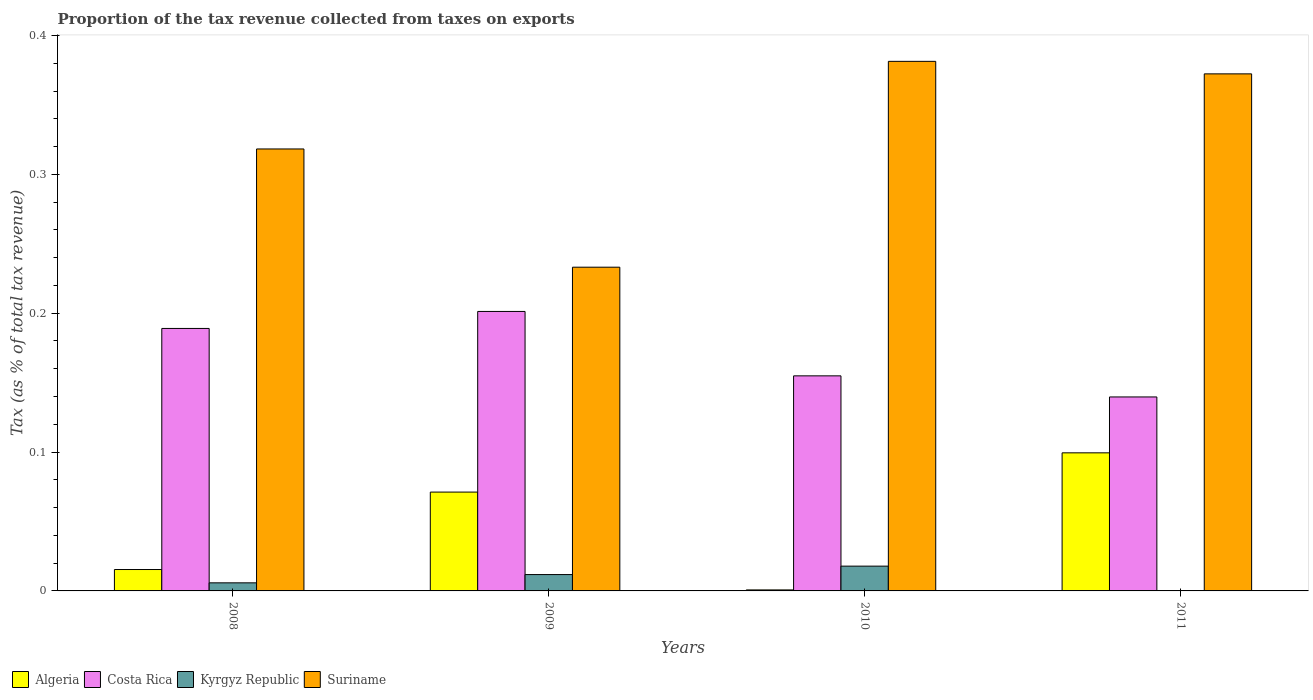How many groups of bars are there?
Your response must be concise. 4. How many bars are there on the 1st tick from the left?
Give a very brief answer. 4. How many bars are there on the 3rd tick from the right?
Provide a succinct answer. 4. What is the label of the 3rd group of bars from the left?
Ensure brevity in your answer.  2010. What is the proportion of the tax revenue collected in Algeria in 2009?
Your response must be concise. 0.07. Across all years, what is the maximum proportion of the tax revenue collected in Costa Rica?
Offer a terse response. 0.2. Across all years, what is the minimum proportion of the tax revenue collected in Suriname?
Your response must be concise. 0.23. What is the total proportion of the tax revenue collected in Algeria in the graph?
Provide a succinct answer. 0.19. What is the difference between the proportion of the tax revenue collected in Suriname in 2009 and that in 2010?
Offer a very short reply. -0.15. What is the difference between the proportion of the tax revenue collected in Algeria in 2011 and the proportion of the tax revenue collected in Costa Rica in 2010?
Make the answer very short. -0.06. What is the average proportion of the tax revenue collected in Costa Rica per year?
Offer a very short reply. 0.17. In the year 2010, what is the difference between the proportion of the tax revenue collected in Suriname and proportion of the tax revenue collected in Costa Rica?
Give a very brief answer. 0.23. What is the ratio of the proportion of the tax revenue collected in Suriname in 2009 to that in 2010?
Keep it short and to the point. 0.61. What is the difference between the highest and the second highest proportion of the tax revenue collected in Suriname?
Offer a very short reply. 0.01. What is the difference between the highest and the lowest proportion of the tax revenue collected in Algeria?
Your answer should be compact. 0.1. Is the sum of the proportion of the tax revenue collected in Costa Rica in 2010 and 2011 greater than the maximum proportion of the tax revenue collected in Algeria across all years?
Offer a very short reply. Yes. Is it the case that in every year, the sum of the proportion of the tax revenue collected in Suriname and proportion of the tax revenue collected in Costa Rica is greater than the sum of proportion of the tax revenue collected in Algeria and proportion of the tax revenue collected in Kyrgyz Republic?
Your answer should be very brief. Yes. How many bars are there?
Offer a terse response. 15. What is the difference between two consecutive major ticks on the Y-axis?
Make the answer very short. 0.1. Does the graph contain grids?
Make the answer very short. No. Where does the legend appear in the graph?
Make the answer very short. Bottom left. What is the title of the graph?
Make the answer very short. Proportion of the tax revenue collected from taxes on exports. Does "Europe(all income levels)" appear as one of the legend labels in the graph?
Make the answer very short. No. What is the label or title of the X-axis?
Your answer should be very brief. Years. What is the label or title of the Y-axis?
Your answer should be compact. Tax (as % of total tax revenue). What is the Tax (as % of total tax revenue) in Algeria in 2008?
Make the answer very short. 0.02. What is the Tax (as % of total tax revenue) in Costa Rica in 2008?
Offer a terse response. 0.19. What is the Tax (as % of total tax revenue) of Kyrgyz Republic in 2008?
Your answer should be very brief. 0.01. What is the Tax (as % of total tax revenue) of Suriname in 2008?
Provide a short and direct response. 0.32. What is the Tax (as % of total tax revenue) of Algeria in 2009?
Your response must be concise. 0.07. What is the Tax (as % of total tax revenue) in Costa Rica in 2009?
Your answer should be compact. 0.2. What is the Tax (as % of total tax revenue) of Kyrgyz Republic in 2009?
Offer a very short reply. 0.01. What is the Tax (as % of total tax revenue) in Suriname in 2009?
Keep it short and to the point. 0.23. What is the Tax (as % of total tax revenue) of Algeria in 2010?
Provide a succinct answer. 0. What is the Tax (as % of total tax revenue) in Costa Rica in 2010?
Provide a succinct answer. 0.15. What is the Tax (as % of total tax revenue) of Kyrgyz Republic in 2010?
Your answer should be very brief. 0.02. What is the Tax (as % of total tax revenue) of Suriname in 2010?
Your answer should be very brief. 0.38. What is the Tax (as % of total tax revenue) in Algeria in 2011?
Keep it short and to the point. 0.1. What is the Tax (as % of total tax revenue) in Costa Rica in 2011?
Provide a succinct answer. 0.14. What is the Tax (as % of total tax revenue) in Kyrgyz Republic in 2011?
Offer a very short reply. 0. What is the Tax (as % of total tax revenue) of Suriname in 2011?
Provide a succinct answer. 0.37. Across all years, what is the maximum Tax (as % of total tax revenue) of Algeria?
Provide a short and direct response. 0.1. Across all years, what is the maximum Tax (as % of total tax revenue) in Costa Rica?
Give a very brief answer. 0.2. Across all years, what is the maximum Tax (as % of total tax revenue) in Kyrgyz Republic?
Give a very brief answer. 0.02. Across all years, what is the maximum Tax (as % of total tax revenue) of Suriname?
Your answer should be compact. 0.38. Across all years, what is the minimum Tax (as % of total tax revenue) in Algeria?
Ensure brevity in your answer.  0. Across all years, what is the minimum Tax (as % of total tax revenue) of Costa Rica?
Provide a short and direct response. 0.14. Across all years, what is the minimum Tax (as % of total tax revenue) in Suriname?
Offer a terse response. 0.23. What is the total Tax (as % of total tax revenue) of Algeria in the graph?
Make the answer very short. 0.19. What is the total Tax (as % of total tax revenue) of Costa Rica in the graph?
Ensure brevity in your answer.  0.68. What is the total Tax (as % of total tax revenue) of Kyrgyz Republic in the graph?
Keep it short and to the point. 0.04. What is the total Tax (as % of total tax revenue) of Suriname in the graph?
Ensure brevity in your answer.  1.31. What is the difference between the Tax (as % of total tax revenue) of Algeria in 2008 and that in 2009?
Your answer should be very brief. -0.06. What is the difference between the Tax (as % of total tax revenue) of Costa Rica in 2008 and that in 2009?
Offer a terse response. -0.01. What is the difference between the Tax (as % of total tax revenue) of Kyrgyz Republic in 2008 and that in 2009?
Your response must be concise. -0.01. What is the difference between the Tax (as % of total tax revenue) in Suriname in 2008 and that in 2009?
Your answer should be compact. 0.09. What is the difference between the Tax (as % of total tax revenue) of Algeria in 2008 and that in 2010?
Your answer should be compact. 0.01. What is the difference between the Tax (as % of total tax revenue) in Costa Rica in 2008 and that in 2010?
Ensure brevity in your answer.  0.03. What is the difference between the Tax (as % of total tax revenue) in Kyrgyz Republic in 2008 and that in 2010?
Your response must be concise. -0.01. What is the difference between the Tax (as % of total tax revenue) of Suriname in 2008 and that in 2010?
Make the answer very short. -0.06. What is the difference between the Tax (as % of total tax revenue) of Algeria in 2008 and that in 2011?
Give a very brief answer. -0.08. What is the difference between the Tax (as % of total tax revenue) of Costa Rica in 2008 and that in 2011?
Your answer should be very brief. 0.05. What is the difference between the Tax (as % of total tax revenue) in Suriname in 2008 and that in 2011?
Keep it short and to the point. -0.05. What is the difference between the Tax (as % of total tax revenue) of Algeria in 2009 and that in 2010?
Offer a very short reply. 0.07. What is the difference between the Tax (as % of total tax revenue) in Costa Rica in 2009 and that in 2010?
Your answer should be very brief. 0.05. What is the difference between the Tax (as % of total tax revenue) of Kyrgyz Republic in 2009 and that in 2010?
Ensure brevity in your answer.  -0.01. What is the difference between the Tax (as % of total tax revenue) in Suriname in 2009 and that in 2010?
Offer a very short reply. -0.15. What is the difference between the Tax (as % of total tax revenue) of Algeria in 2009 and that in 2011?
Provide a succinct answer. -0.03. What is the difference between the Tax (as % of total tax revenue) in Costa Rica in 2009 and that in 2011?
Ensure brevity in your answer.  0.06. What is the difference between the Tax (as % of total tax revenue) of Suriname in 2009 and that in 2011?
Offer a terse response. -0.14. What is the difference between the Tax (as % of total tax revenue) of Algeria in 2010 and that in 2011?
Offer a terse response. -0.1. What is the difference between the Tax (as % of total tax revenue) of Costa Rica in 2010 and that in 2011?
Offer a terse response. 0.02. What is the difference between the Tax (as % of total tax revenue) in Suriname in 2010 and that in 2011?
Make the answer very short. 0.01. What is the difference between the Tax (as % of total tax revenue) in Algeria in 2008 and the Tax (as % of total tax revenue) in Costa Rica in 2009?
Your answer should be compact. -0.19. What is the difference between the Tax (as % of total tax revenue) of Algeria in 2008 and the Tax (as % of total tax revenue) of Kyrgyz Republic in 2009?
Keep it short and to the point. 0. What is the difference between the Tax (as % of total tax revenue) in Algeria in 2008 and the Tax (as % of total tax revenue) in Suriname in 2009?
Ensure brevity in your answer.  -0.22. What is the difference between the Tax (as % of total tax revenue) of Costa Rica in 2008 and the Tax (as % of total tax revenue) of Kyrgyz Republic in 2009?
Your answer should be compact. 0.18. What is the difference between the Tax (as % of total tax revenue) of Costa Rica in 2008 and the Tax (as % of total tax revenue) of Suriname in 2009?
Your answer should be compact. -0.04. What is the difference between the Tax (as % of total tax revenue) of Kyrgyz Republic in 2008 and the Tax (as % of total tax revenue) of Suriname in 2009?
Your response must be concise. -0.23. What is the difference between the Tax (as % of total tax revenue) in Algeria in 2008 and the Tax (as % of total tax revenue) in Costa Rica in 2010?
Provide a short and direct response. -0.14. What is the difference between the Tax (as % of total tax revenue) of Algeria in 2008 and the Tax (as % of total tax revenue) of Kyrgyz Republic in 2010?
Make the answer very short. -0. What is the difference between the Tax (as % of total tax revenue) in Algeria in 2008 and the Tax (as % of total tax revenue) in Suriname in 2010?
Ensure brevity in your answer.  -0.37. What is the difference between the Tax (as % of total tax revenue) in Costa Rica in 2008 and the Tax (as % of total tax revenue) in Kyrgyz Republic in 2010?
Your answer should be compact. 0.17. What is the difference between the Tax (as % of total tax revenue) in Costa Rica in 2008 and the Tax (as % of total tax revenue) in Suriname in 2010?
Provide a short and direct response. -0.19. What is the difference between the Tax (as % of total tax revenue) in Kyrgyz Republic in 2008 and the Tax (as % of total tax revenue) in Suriname in 2010?
Give a very brief answer. -0.38. What is the difference between the Tax (as % of total tax revenue) in Algeria in 2008 and the Tax (as % of total tax revenue) in Costa Rica in 2011?
Offer a very short reply. -0.12. What is the difference between the Tax (as % of total tax revenue) in Algeria in 2008 and the Tax (as % of total tax revenue) in Suriname in 2011?
Ensure brevity in your answer.  -0.36. What is the difference between the Tax (as % of total tax revenue) in Costa Rica in 2008 and the Tax (as % of total tax revenue) in Suriname in 2011?
Make the answer very short. -0.18. What is the difference between the Tax (as % of total tax revenue) of Kyrgyz Republic in 2008 and the Tax (as % of total tax revenue) of Suriname in 2011?
Keep it short and to the point. -0.37. What is the difference between the Tax (as % of total tax revenue) of Algeria in 2009 and the Tax (as % of total tax revenue) of Costa Rica in 2010?
Make the answer very short. -0.08. What is the difference between the Tax (as % of total tax revenue) in Algeria in 2009 and the Tax (as % of total tax revenue) in Kyrgyz Republic in 2010?
Make the answer very short. 0.05. What is the difference between the Tax (as % of total tax revenue) in Algeria in 2009 and the Tax (as % of total tax revenue) in Suriname in 2010?
Make the answer very short. -0.31. What is the difference between the Tax (as % of total tax revenue) of Costa Rica in 2009 and the Tax (as % of total tax revenue) of Kyrgyz Republic in 2010?
Make the answer very short. 0.18. What is the difference between the Tax (as % of total tax revenue) in Costa Rica in 2009 and the Tax (as % of total tax revenue) in Suriname in 2010?
Ensure brevity in your answer.  -0.18. What is the difference between the Tax (as % of total tax revenue) of Kyrgyz Republic in 2009 and the Tax (as % of total tax revenue) of Suriname in 2010?
Offer a terse response. -0.37. What is the difference between the Tax (as % of total tax revenue) of Algeria in 2009 and the Tax (as % of total tax revenue) of Costa Rica in 2011?
Ensure brevity in your answer.  -0.07. What is the difference between the Tax (as % of total tax revenue) in Algeria in 2009 and the Tax (as % of total tax revenue) in Suriname in 2011?
Keep it short and to the point. -0.3. What is the difference between the Tax (as % of total tax revenue) of Costa Rica in 2009 and the Tax (as % of total tax revenue) of Suriname in 2011?
Make the answer very short. -0.17. What is the difference between the Tax (as % of total tax revenue) in Kyrgyz Republic in 2009 and the Tax (as % of total tax revenue) in Suriname in 2011?
Give a very brief answer. -0.36. What is the difference between the Tax (as % of total tax revenue) in Algeria in 2010 and the Tax (as % of total tax revenue) in Costa Rica in 2011?
Provide a succinct answer. -0.14. What is the difference between the Tax (as % of total tax revenue) in Algeria in 2010 and the Tax (as % of total tax revenue) in Suriname in 2011?
Give a very brief answer. -0.37. What is the difference between the Tax (as % of total tax revenue) in Costa Rica in 2010 and the Tax (as % of total tax revenue) in Suriname in 2011?
Provide a short and direct response. -0.22. What is the difference between the Tax (as % of total tax revenue) of Kyrgyz Republic in 2010 and the Tax (as % of total tax revenue) of Suriname in 2011?
Make the answer very short. -0.35. What is the average Tax (as % of total tax revenue) in Algeria per year?
Provide a succinct answer. 0.05. What is the average Tax (as % of total tax revenue) of Costa Rica per year?
Make the answer very short. 0.17. What is the average Tax (as % of total tax revenue) of Kyrgyz Republic per year?
Your answer should be compact. 0.01. What is the average Tax (as % of total tax revenue) in Suriname per year?
Offer a very short reply. 0.33. In the year 2008, what is the difference between the Tax (as % of total tax revenue) of Algeria and Tax (as % of total tax revenue) of Costa Rica?
Provide a short and direct response. -0.17. In the year 2008, what is the difference between the Tax (as % of total tax revenue) of Algeria and Tax (as % of total tax revenue) of Kyrgyz Republic?
Ensure brevity in your answer.  0.01. In the year 2008, what is the difference between the Tax (as % of total tax revenue) of Algeria and Tax (as % of total tax revenue) of Suriname?
Your response must be concise. -0.3. In the year 2008, what is the difference between the Tax (as % of total tax revenue) in Costa Rica and Tax (as % of total tax revenue) in Kyrgyz Republic?
Your response must be concise. 0.18. In the year 2008, what is the difference between the Tax (as % of total tax revenue) of Costa Rica and Tax (as % of total tax revenue) of Suriname?
Your response must be concise. -0.13. In the year 2008, what is the difference between the Tax (as % of total tax revenue) in Kyrgyz Republic and Tax (as % of total tax revenue) in Suriname?
Offer a very short reply. -0.31. In the year 2009, what is the difference between the Tax (as % of total tax revenue) in Algeria and Tax (as % of total tax revenue) in Costa Rica?
Your response must be concise. -0.13. In the year 2009, what is the difference between the Tax (as % of total tax revenue) in Algeria and Tax (as % of total tax revenue) in Kyrgyz Republic?
Provide a short and direct response. 0.06. In the year 2009, what is the difference between the Tax (as % of total tax revenue) in Algeria and Tax (as % of total tax revenue) in Suriname?
Make the answer very short. -0.16. In the year 2009, what is the difference between the Tax (as % of total tax revenue) of Costa Rica and Tax (as % of total tax revenue) of Kyrgyz Republic?
Your answer should be compact. 0.19. In the year 2009, what is the difference between the Tax (as % of total tax revenue) in Costa Rica and Tax (as % of total tax revenue) in Suriname?
Your answer should be compact. -0.03. In the year 2009, what is the difference between the Tax (as % of total tax revenue) in Kyrgyz Republic and Tax (as % of total tax revenue) in Suriname?
Make the answer very short. -0.22. In the year 2010, what is the difference between the Tax (as % of total tax revenue) of Algeria and Tax (as % of total tax revenue) of Costa Rica?
Your response must be concise. -0.15. In the year 2010, what is the difference between the Tax (as % of total tax revenue) in Algeria and Tax (as % of total tax revenue) in Kyrgyz Republic?
Provide a short and direct response. -0.02. In the year 2010, what is the difference between the Tax (as % of total tax revenue) in Algeria and Tax (as % of total tax revenue) in Suriname?
Offer a terse response. -0.38. In the year 2010, what is the difference between the Tax (as % of total tax revenue) of Costa Rica and Tax (as % of total tax revenue) of Kyrgyz Republic?
Offer a very short reply. 0.14. In the year 2010, what is the difference between the Tax (as % of total tax revenue) in Costa Rica and Tax (as % of total tax revenue) in Suriname?
Ensure brevity in your answer.  -0.23. In the year 2010, what is the difference between the Tax (as % of total tax revenue) in Kyrgyz Republic and Tax (as % of total tax revenue) in Suriname?
Your answer should be very brief. -0.36. In the year 2011, what is the difference between the Tax (as % of total tax revenue) of Algeria and Tax (as % of total tax revenue) of Costa Rica?
Offer a terse response. -0.04. In the year 2011, what is the difference between the Tax (as % of total tax revenue) in Algeria and Tax (as % of total tax revenue) in Suriname?
Your answer should be very brief. -0.27. In the year 2011, what is the difference between the Tax (as % of total tax revenue) in Costa Rica and Tax (as % of total tax revenue) in Suriname?
Provide a short and direct response. -0.23. What is the ratio of the Tax (as % of total tax revenue) in Algeria in 2008 to that in 2009?
Your answer should be very brief. 0.22. What is the ratio of the Tax (as % of total tax revenue) of Costa Rica in 2008 to that in 2009?
Your response must be concise. 0.94. What is the ratio of the Tax (as % of total tax revenue) in Kyrgyz Republic in 2008 to that in 2009?
Provide a short and direct response. 0.49. What is the ratio of the Tax (as % of total tax revenue) of Suriname in 2008 to that in 2009?
Your answer should be very brief. 1.37. What is the ratio of the Tax (as % of total tax revenue) in Algeria in 2008 to that in 2010?
Ensure brevity in your answer.  21.19. What is the ratio of the Tax (as % of total tax revenue) in Costa Rica in 2008 to that in 2010?
Your response must be concise. 1.22. What is the ratio of the Tax (as % of total tax revenue) in Kyrgyz Republic in 2008 to that in 2010?
Provide a short and direct response. 0.33. What is the ratio of the Tax (as % of total tax revenue) of Suriname in 2008 to that in 2010?
Give a very brief answer. 0.83. What is the ratio of the Tax (as % of total tax revenue) of Algeria in 2008 to that in 2011?
Make the answer very short. 0.15. What is the ratio of the Tax (as % of total tax revenue) in Costa Rica in 2008 to that in 2011?
Your answer should be very brief. 1.35. What is the ratio of the Tax (as % of total tax revenue) in Suriname in 2008 to that in 2011?
Give a very brief answer. 0.85. What is the ratio of the Tax (as % of total tax revenue) in Algeria in 2009 to that in 2010?
Provide a succinct answer. 97.89. What is the ratio of the Tax (as % of total tax revenue) in Costa Rica in 2009 to that in 2010?
Your answer should be very brief. 1.3. What is the ratio of the Tax (as % of total tax revenue) in Kyrgyz Republic in 2009 to that in 2010?
Provide a succinct answer. 0.66. What is the ratio of the Tax (as % of total tax revenue) in Suriname in 2009 to that in 2010?
Your answer should be very brief. 0.61. What is the ratio of the Tax (as % of total tax revenue) in Algeria in 2009 to that in 2011?
Your answer should be compact. 0.72. What is the ratio of the Tax (as % of total tax revenue) of Costa Rica in 2009 to that in 2011?
Your response must be concise. 1.44. What is the ratio of the Tax (as % of total tax revenue) of Suriname in 2009 to that in 2011?
Provide a succinct answer. 0.63. What is the ratio of the Tax (as % of total tax revenue) in Algeria in 2010 to that in 2011?
Keep it short and to the point. 0.01. What is the ratio of the Tax (as % of total tax revenue) in Costa Rica in 2010 to that in 2011?
Ensure brevity in your answer.  1.11. What is the ratio of the Tax (as % of total tax revenue) of Suriname in 2010 to that in 2011?
Your answer should be compact. 1.02. What is the difference between the highest and the second highest Tax (as % of total tax revenue) in Algeria?
Ensure brevity in your answer.  0.03. What is the difference between the highest and the second highest Tax (as % of total tax revenue) in Costa Rica?
Your answer should be very brief. 0.01. What is the difference between the highest and the second highest Tax (as % of total tax revenue) in Kyrgyz Republic?
Offer a very short reply. 0.01. What is the difference between the highest and the second highest Tax (as % of total tax revenue) of Suriname?
Your answer should be very brief. 0.01. What is the difference between the highest and the lowest Tax (as % of total tax revenue) in Algeria?
Your response must be concise. 0.1. What is the difference between the highest and the lowest Tax (as % of total tax revenue) in Costa Rica?
Provide a succinct answer. 0.06. What is the difference between the highest and the lowest Tax (as % of total tax revenue) of Kyrgyz Republic?
Offer a very short reply. 0.02. What is the difference between the highest and the lowest Tax (as % of total tax revenue) of Suriname?
Provide a short and direct response. 0.15. 